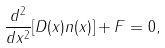<formula> <loc_0><loc_0><loc_500><loc_500>\frac { d ^ { 2 } } { d x ^ { 2 } } [ D ( x ) n ( x ) ] + F = 0 ,</formula> 